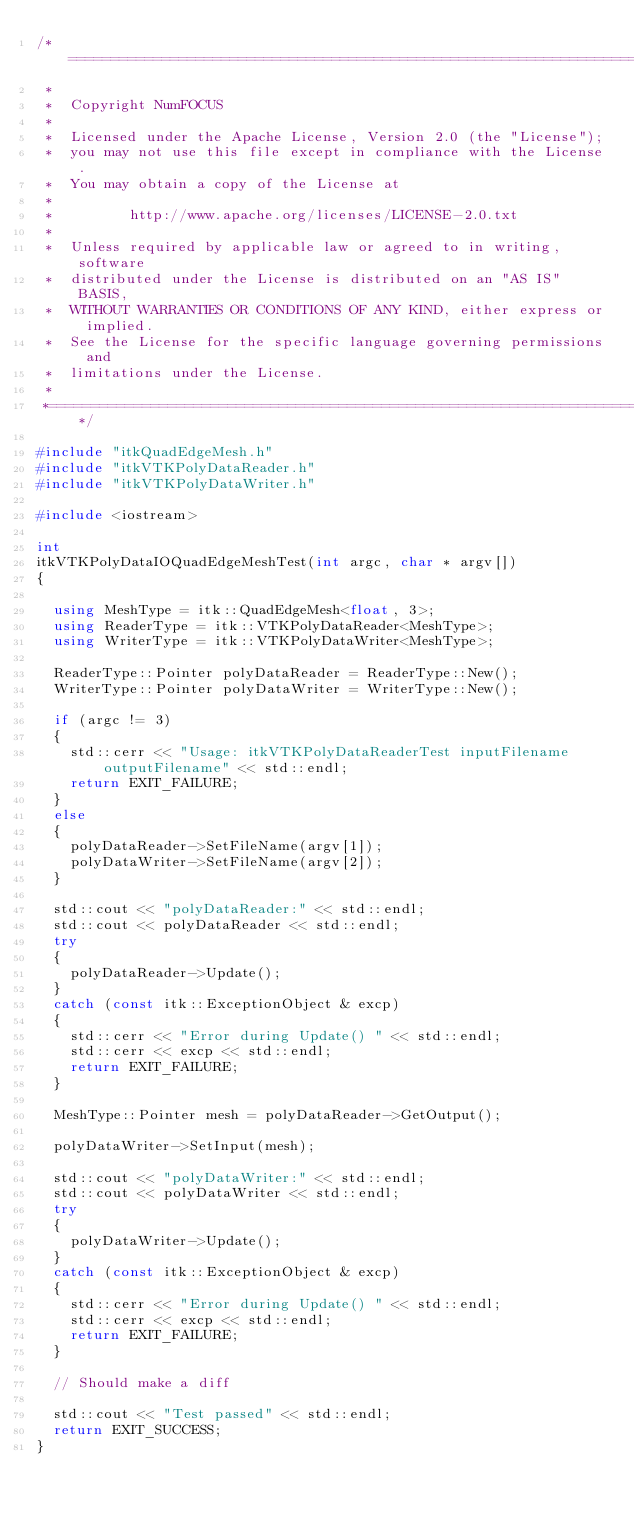<code> <loc_0><loc_0><loc_500><loc_500><_C++_>/*=========================================================================
 *
 *  Copyright NumFOCUS
 *
 *  Licensed under the Apache License, Version 2.0 (the "License");
 *  you may not use this file except in compliance with the License.
 *  You may obtain a copy of the License at
 *
 *         http://www.apache.org/licenses/LICENSE-2.0.txt
 *
 *  Unless required by applicable law or agreed to in writing, software
 *  distributed under the License is distributed on an "AS IS" BASIS,
 *  WITHOUT WARRANTIES OR CONDITIONS OF ANY KIND, either express or implied.
 *  See the License for the specific language governing permissions and
 *  limitations under the License.
 *
 *=========================================================================*/

#include "itkQuadEdgeMesh.h"
#include "itkVTKPolyDataReader.h"
#include "itkVTKPolyDataWriter.h"

#include <iostream>

int
itkVTKPolyDataIOQuadEdgeMeshTest(int argc, char * argv[])
{

  using MeshType = itk::QuadEdgeMesh<float, 3>;
  using ReaderType = itk::VTKPolyDataReader<MeshType>;
  using WriterType = itk::VTKPolyDataWriter<MeshType>;

  ReaderType::Pointer polyDataReader = ReaderType::New();
  WriterType::Pointer polyDataWriter = WriterType::New();

  if (argc != 3)
  {
    std::cerr << "Usage: itkVTKPolyDataReaderTest inputFilename outputFilename" << std::endl;
    return EXIT_FAILURE;
  }
  else
  {
    polyDataReader->SetFileName(argv[1]);
    polyDataWriter->SetFileName(argv[2]);
  }

  std::cout << "polyDataReader:" << std::endl;
  std::cout << polyDataReader << std::endl;
  try
  {
    polyDataReader->Update();
  }
  catch (const itk::ExceptionObject & excp)
  {
    std::cerr << "Error during Update() " << std::endl;
    std::cerr << excp << std::endl;
    return EXIT_FAILURE;
  }

  MeshType::Pointer mesh = polyDataReader->GetOutput();

  polyDataWriter->SetInput(mesh);

  std::cout << "polyDataWriter:" << std::endl;
  std::cout << polyDataWriter << std::endl;
  try
  {
    polyDataWriter->Update();
  }
  catch (const itk::ExceptionObject & excp)
  {
    std::cerr << "Error during Update() " << std::endl;
    std::cerr << excp << std::endl;
    return EXIT_FAILURE;
  }

  // Should make a diff

  std::cout << "Test passed" << std::endl;
  return EXIT_SUCCESS;
}
</code> 